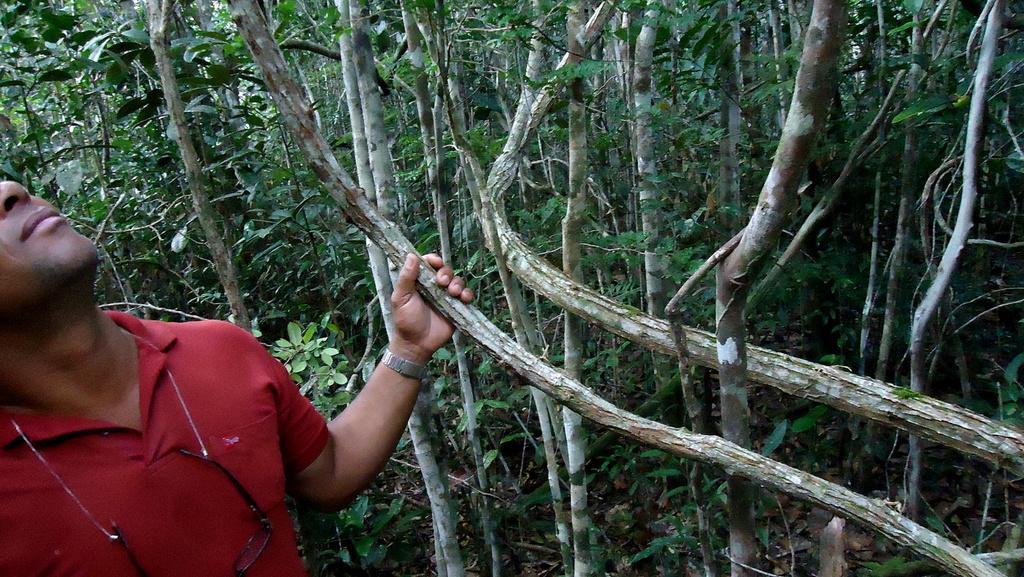How would you summarize this image in a sentence or two? In the image we can see there is a man standing and he is holding tree trunk. Behind there are lot of trees and there are spectacles tied to a rope. 